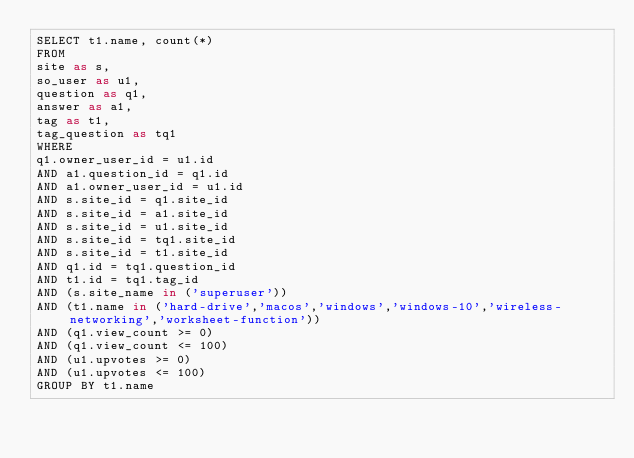<code> <loc_0><loc_0><loc_500><loc_500><_SQL_>SELECT t1.name, count(*)
FROM
site as s,
so_user as u1,
question as q1,
answer as a1,
tag as t1,
tag_question as tq1
WHERE
q1.owner_user_id = u1.id
AND a1.question_id = q1.id
AND a1.owner_user_id = u1.id
AND s.site_id = q1.site_id
AND s.site_id = a1.site_id
AND s.site_id = u1.site_id
AND s.site_id = tq1.site_id
AND s.site_id = t1.site_id
AND q1.id = tq1.question_id
AND t1.id = tq1.tag_id
AND (s.site_name in ('superuser'))
AND (t1.name in ('hard-drive','macos','windows','windows-10','wireless-networking','worksheet-function'))
AND (q1.view_count >= 0)
AND (q1.view_count <= 100)
AND (u1.upvotes >= 0)
AND (u1.upvotes <= 100)
GROUP BY t1.name</code> 